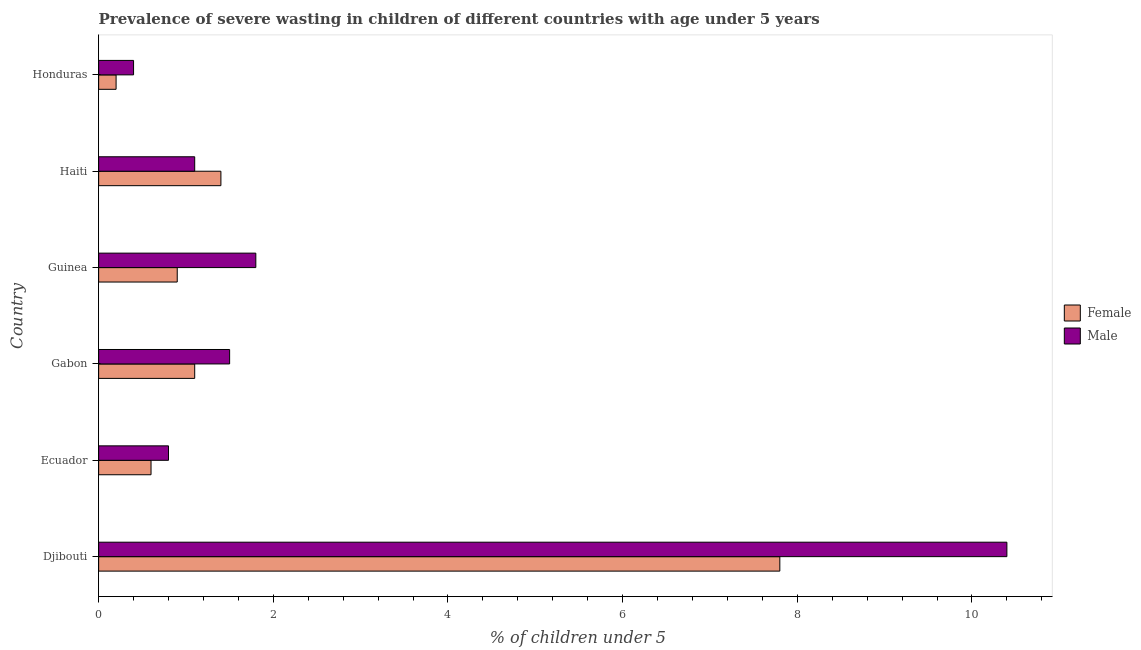How many groups of bars are there?
Provide a succinct answer. 6. Are the number of bars per tick equal to the number of legend labels?
Keep it short and to the point. Yes. How many bars are there on the 1st tick from the top?
Provide a short and direct response. 2. How many bars are there on the 6th tick from the bottom?
Offer a very short reply. 2. What is the label of the 2nd group of bars from the top?
Your answer should be compact. Haiti. In how many cases, is the number of bars for a given country not equal to the number of legend labels?
Give a very brief answer. 0. What is the percentage of undernourished male children in Ecuador?
Provide a short and direct response. 0.8. Across all countries, what is the maximum percentage of undernourished female children?
Make the answer very short. 7.8. Across all countries, what is the minimum percentage of undernourished female children?
Your response must be concise. 0.2. In which country was the percentage of undernourished male children maximum?
Offer a terse response. Djibouti. In which country was the percentage of undernourished male children minimum?
Provide a short and direct response. Honduras. What is the total percentage of undernourished male children in the graph?
Keep it short and to the point. 16. What is the difference between the percentage of undernourished female children in Ecuador and that in Haiti?
Keep it short and to the point. -0.8. What is the difference between the percentage of undernourished male children in Honduras and the percentage of undernourished female children in Gabon?
Offer a terse response. -0.7. What is the average percentage of undernourished male children per country?
Provide a short and direct response. 2.67. What is the ratio of the percentage of undernourished female children in Gabon to that in Haiti?
Make the answer very short. 0.79. Is the difference between the percentage of undernourished male children in Guinea and Haiti greater than the difference between the percentage of undernourished female children in Guinea and Haiti?
Offer a very short reply. Yes. Are all the bars in the graph horizontal?
Your response must be concise. Yes. How many countries are there in the graph?
Ensure brevity in your answer.  6. Are the values on the major ticks of X-axis written in scientific E-notation?
Make the answer very short. No. Does the graph contain any zero values?
Your answer should be very brief. No. Where does the legend appear in the graph?
Provide a succinct answer. Center right. How many legend labels are there?
Offer a very short reply. 2. What is the title of the graph?
Give a very brief answer. Prevalence of severe wasting in children of different countries with age under 5 years. What is the label or title of the X-axis?
Your answer should be compact.  % of children under 5. What is the label or title of the Y-axis?
Offer a terse response. Country. What is the  % of children under 5 of Female in Djibouti?
Your response must be concise. 7.8. What is the  % of children under 5 of Male in Djibouti?
Ensure brevity in your answer.  10.4. What is the  % of children under 5 in Female in Ecuador?
Give a very brief answer. 0.6. What is the  % of children under 5 of Male in Ecuador?
Your answer should be compact. 0.8. What is the  % of children under 5 in Female in Gabon?
Keep it short and to the point. 1.1. What is the  % of children under 5 in Male in Gabon?
Keep it short and to the point. 1.5. What is the  % of children under 5 of Female in Guinea?
Give a very brief answer. 0.9. What is the  % of children under 5 in Male in Guinea?
Provide a short and direct response. 1.8. What is the  % of children under 5 of Female in Haiti?
Keep it short and to the point. 1.4. What is the  % of children under 5 in Male in Haiti?
Your answer should be compact. 1.1. What is the  % of children under 5 of Female in Honduras?
Provide a succinct answer. 0.2. What is the  % of children under 5 of Male in Honduras?
Provide a short and direct response. 0.4. Across all countries, what is the maximum  % of children under 5 in Female?
Provide a succinct answer. 7.8. Across all countries, what is the maximum  % of children under 5 in Male?
Keep it short and to the point. 10.4. Across all countries, what is the minimum  % of children under 5 in Female?
Ensure brevity in your answer.  0.2. Across all countries, what is the minimum  % of children under 5 of Male?
Your answer should be compact. 0.4. What is the total  % of children under 5 of Male in the graph?
Provide a succinct answer. 16. What is the difference between the  % of children under 5 in Male in Djibouti and that in Gabon?
Ensure brevity in your answer.  8.9. What is the difference between the  % of children under 5 in Female in Djibouti and that in Guinea?
Keep it short and to the point. 6.9. What is the difference between the  % of children under 5 of Male in Djibouti and that in Guinea?
Provide a succinct answer. 8.6. What is the difference between the  % of children under 5 in Female in Djibouti and that in Haiti?
Ensure brevity in your answer.  6.4. What is the difference between the  % of children under 5 in Male in Djibouti and that in Haiti?
Give a very brief answer. 9.3. What is the difference between the  % of children under 5 in Female in Djibouti and that in Honduras?
Your response must be concise. 7.6. What is the difference between the  % of children under 5 of Male in Djibouti and that in Honduras?
Ensure brevity in your answer.  10. What is the difference between the  % of children under 5 of Female in Ecuador and that in Gabon?
Offer a very short reply. -0.5. What is the difference between the  % of children under 5 in Male in Ecuador and that in Gabon?
Give a very brief answer. -0.7. What is the difference between the  % of children under 5 in Female in Ecuador and that in Haiti?
Make the answer very short. -0.8. What is the difference between the  % of children under 5 of Female in Ecuador and that in Honduras?
Offer a very short reply. 0.4. What is the difference between the  % of children under 5 in Male in Ecuador and that in Honduras?
Your answer should be very brief. 0.4. What is the difference between the  % of children under 5 of Female in Gabon and that in Guinea?
Provide a short and direct response. 0.2. What is the difference between the  % of children under 5 in Male in Gabon and that in Haiti?
Keep it short and to the point. 0.4. What is the difference between the  % of children under 5 of Female in Gabon and that in Honduras?
Your response must be concise. 0.9. What is the difference between the  % of children under 5 of Male in Gabon and that in Honduras?
Make the answer very short. 1.1. What is the difference between the  % of children under 5 of Male in Guinea and that in Haiti?
Your answer should be compact. 0.7. What is the difference between the  % of children under 5 of Female in Haiti and that in Honduras?
Provide a short and direct response. 1.2. What is the difference between the  % of children under 5 in Female in Djibouti and the  % of children under 5 in Male in Ecuador?
Offer a very short reply. 7. What is the difference between the  % of children under 5 in Female in Djibouti and the  % of children under 5 in Male in Haiti?
Offer a very short reply. 6.7. What is the difference between the  % of children under 5 of Female in Gabon and the  % of children under 5 of Male in Guinea?
Your answer should be compact. -0.7. What is the difference between the  % of children under 5 in Female in Gabon and the  % of children under 5 in Male in Haiti?
Your answer should be compact. 0. What is the difference between the  % of children under 5 of Female in Guinea and the  % of children under 5 of Male in Haiti?
Make the answer very short. -0.2. What is the difference between the  % of children under 5 of Female in Guinea and the  % of children under 5 of Male in Honduras?
Make the answer very short. 0.5. What is the difference between the  % of children under 5 of Female in Haiti and the  % of children under 5 of Male in Honduras?
Your answer should be very brief. 1. What is the average  % of children under 5 in Female per country?
Your response must be concise. 2. What is the average  % of children under 5 of Male per country?
Give a very brief answer. 2.67. What is the difference between the  % of children under 5 in Female and  % of children under 5 in Male in Ecuador?
Provide a succinct answer. -0.2. What is the difference between the  % of children under 5 of Female and  % of children under 5 of Male in Gabon?
Offer a terse response. -0.4. What is the difference between the  % of children under 5 of Female and  % of children under 5 of Male in Guinea?
Keep it short and to the point. -0.9. What is the difference between the  % of children under 5 in Female and  % of children under 5 in Male in Haiti?
Give a very brief answer. 0.3. What is the difference between the  % of children under 5 in Female and  % of children under 5 in Male in Honduras?
Ensure brevity in your answer.  -0.2. What is the ratio of the  % of children under 5 of Female in Djibouti to that in Ecuador?
Provide a succinct answer. 13. What is the ratio of the  % of children under 5 of Male in Djibouti to that in Ecuador?
Your answer should be compact. 13. What is the ratio of the  % of children under 5 in Female in Djibouti to that in Gabon?
Make the answer very short. 7.09. What is the ratio of the  % of children under 5 in Male in Djibouti to that in Gabon?
Offer a very short reply. 6.93. What is the ratio of the  % of children under 5 of Female in Djibouti to that in Guinea?
Give a very brief answer. 8.67. What is the ratio of the  % of children under 5 of Male in Djibouti to that in Guinea?
Make the answer very short. 5.78. What is the ratio of the  % of children under 5 of Female in Djibouti to that in Haiti?
Make the answer very short. 5.57. What is the ratio of the  % of children under 5 of Male in Djibouti to that in Haiti?
Ensure brevity in your answer.  9.45. What is the ratio of the  % of children under 5 in Female in Djibouti to that in Honduras?
Ensure brevity in your answer.  39. What is the ratio of the  % of children under 5 of Male in Djibouti to that in Honduras?
Give a very brief answer. 26. What is the ratio of the  % of children under 5 of Female in Ecuador to that in Gabon?
Make the answer very short. 0.55. What is the ratio of the  % of children under 5 in Male in Ecuador to that in Gabon?
Offer a very short reply. 0.53. What is the ratio of the  % of children under 5 in Female in Ecuador to that in Guinea?
Ensure brevity in your answer.  0.67. What is the ratio of the  % of children under 5 in Male in Ecuador to that in Guinea?
Provide a short and direct response. 0.44. What is the ratio of the  % of children under 5 of Female in Ecuador to that in Haiti?
Your response must be concise. 0.43. What is the ratio of the  % of children under 5 in Male in Ecuador to that in Haiti?
Offer a very short reply. 0.73. What is the ratio of the  % of children under 5 in Female in Ecuador to that in Honduras?
Offer a very short reply. 3. What is the ratio of the  % of children under 5 in Male in Ecuador to that in Honduras?
Give a very brief answer. 2. What is the ratio of the  % of children under 5 of Female in Gabon to that in Guinea?
Your answer should be very brief. 1.22. What is the ratio of the  % of children under 5 of Male in Gabon to that in Guinea?
Give a very brief answer. 0.83. What is the ratio of the  % of children under 5 in Female in Gabon to that in Haiti?
Make the answer very short. 0.79. What is the ratio of the  % of children under 5 of Male in Gabon to that in Haiti?
Offer a very short reply. 1.36. What is the ratio of the  % of children under 5 of Male in Gabon to that in Honduras?
Keep it short and to the point. 3.75. What is the ratio of the  % of children under 5 in Female in Guinea to that in Haiti?
Provide a succinct answer. 0.64. What is the ratio of the  % of children under 5 in Male in Guinea to that in Haiti?
Your answer should be very brief. 1.64. What is the ratio of the  % of children under 5 of Female in Guinea to that in Honduras?
Offer a very short reply. 4.5. What is the ratio of the  % of children under 5 of Male in Guinea to that in Honduras?
Your response must be concise. 4.5. What is the ratio of the  % of children under 5 in Male in Haiti to that in Honduras?
Keep it short and to the point. 2.75. What is the difference between the highest and the second highest  % of children under 5 of Female?
Make the answer very short. 6.4. What is the difference between the highest and the lowest  % of children under 5 of Male?
Offer a terse response. 10. 